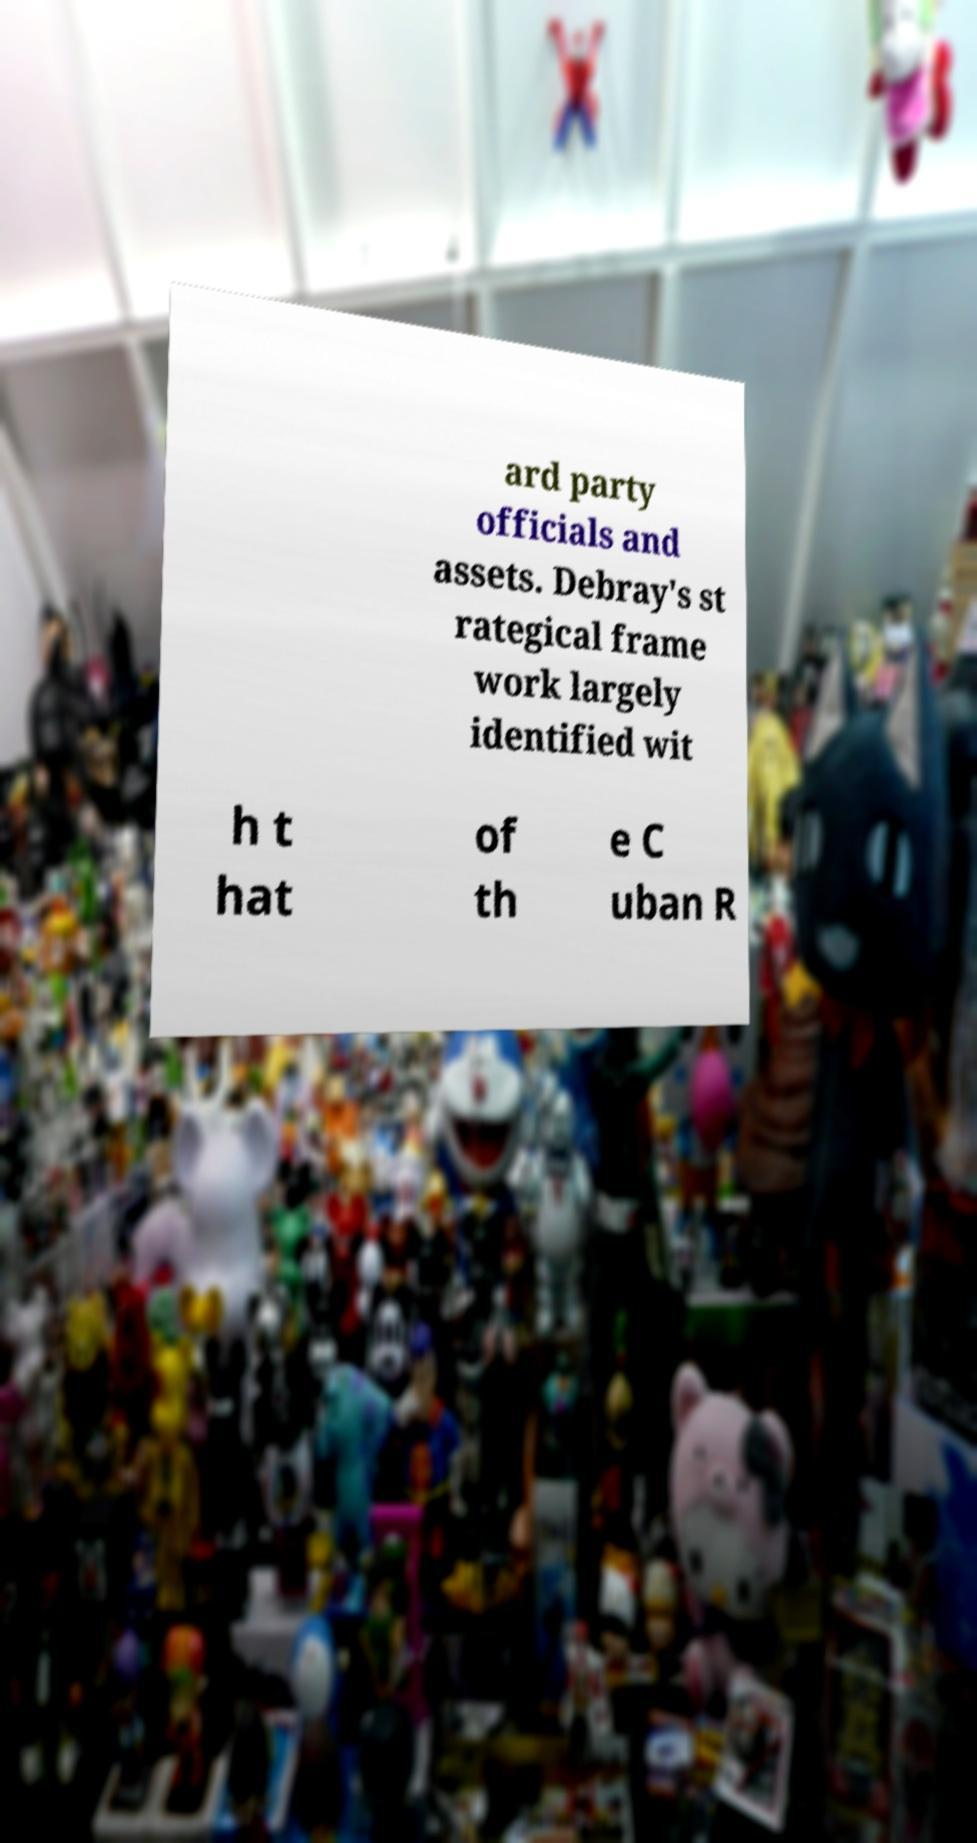There's text embedded in this image that I need extracted. Can you transcribe it verbatim? ard party officials and assets. Debray's st rategical frame work largely identified wit h t hat of th e C uban R 